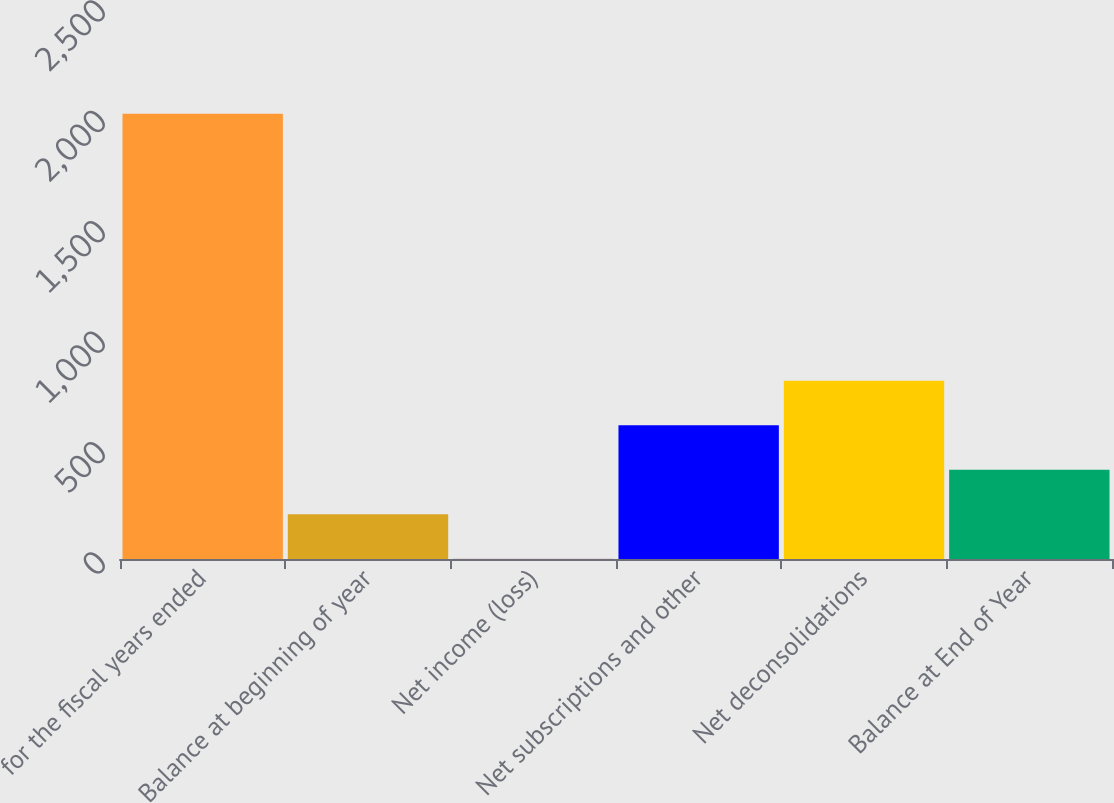Convert chart. <chart><loc_0><loc_0><loc_500><loc_500><bar_chart><fcel>for the fiscal years ended<fcel>Balance at beginning of year<fcel>Net income (loss)<fcel>Net subscriptions and other<fcel>Net deconsolidations<fcel>Balance at End of Year<nl><fcel>2016<fcel>203.04<fcel>1.6<fcel>605.92<fcel>807.36<fcel>404.48<nl></chart> 